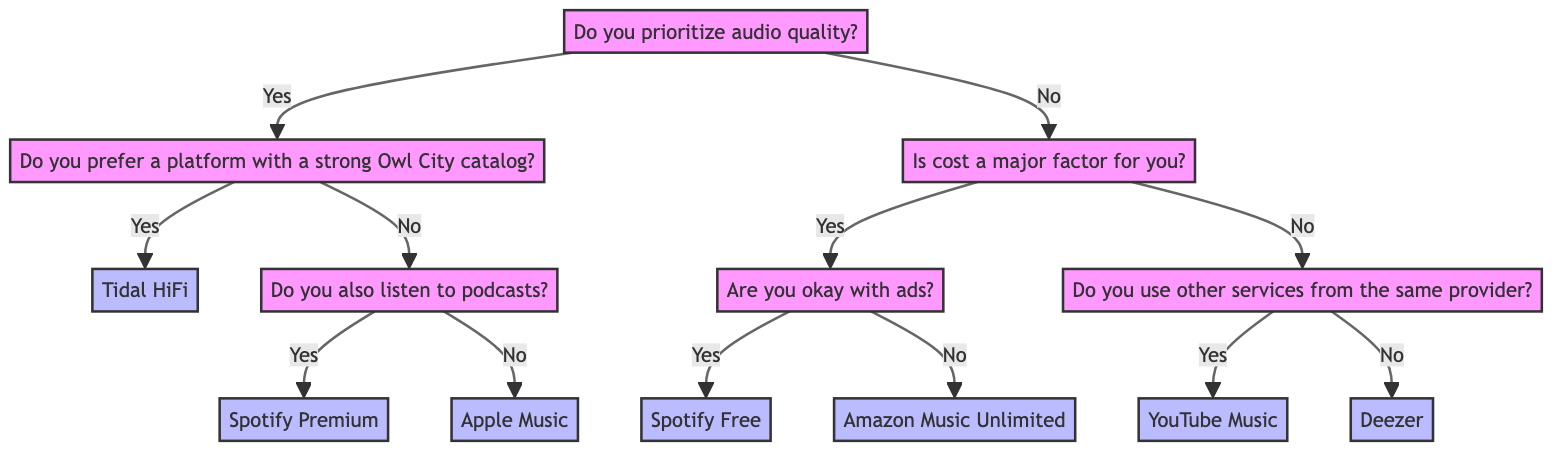What is the root question of the decision tree? The root question of the decision tree is "Do you prioritize audio quality?" This is where the decision-making process begins and divides the paths based on the user's preference for audio quality.
Answer: Do you prioritize audio quality? How many service recommendations are there in total? In the diagram, there are six service recommendations: Tidal HiFi, Spotify Premium, Apple Music, Spotify Free, Amazon Music Unlimited, YouTube Music, and Deezer. Counting these gives a total of seven service recommendations.
Answer: Seven What happens if a user prefers a platform with a strong Owl City catalog? If a user answers "Yes" to preferring a platform with a strong Owl City catalog, they are recommended "Tidal HiFi." This is a direct pathway from the node about preferring audio quality and the strong catalog.
Answer: Tidal HiFi If someone does not prioritize audio quality and cost is not a major factor, what service do they get? The pathway for users who do not prioritize audio quality and find cost not to be a major factor leads to the node asking if they use other services from the same provider. If their answer is "No," they are recommended "Deezer." This follows a decision from no to quality and no to cost.
Answer: Deezer What service is recommended for users who listen to podcasts and prioritize audio quality? For users who listen to podcasts, the tree indicates a pathway that begins from prioritizing audio quality. Since they would choose "No" to having a strong Owl City catalog, they are directed to "Spotify Premium" which is based on the user also listening to podcasts.
Answer: Spotify Premium What is the immediate next question if cost is a major factor? If cost is a major factor, the immediate next question asked by the decision tree is "Are you okay with ads?" This question helps to further narrow down the choice between services based on user preferences regarding ad presence.
Answer: Are you okay with ads? If a user uses other Google services, which music service do they end up with? Users who respond "Yes" to using other services from the same provider will be recommended "YouTube Music." This follows the direct path from the cost question to one regarding other services, leading them to this specific service.
Answer: YouTube Music What service is suggested for users who do not want ads and consider cost as a major factor? The recommendation for users who do not want ads but still consider cost as a major factor is "Amazon Music Unlimited." This is the outcome derived from the decision path leading from the cost factor straight to the preference about ads.
Answer: Amazon Music Unlimited 